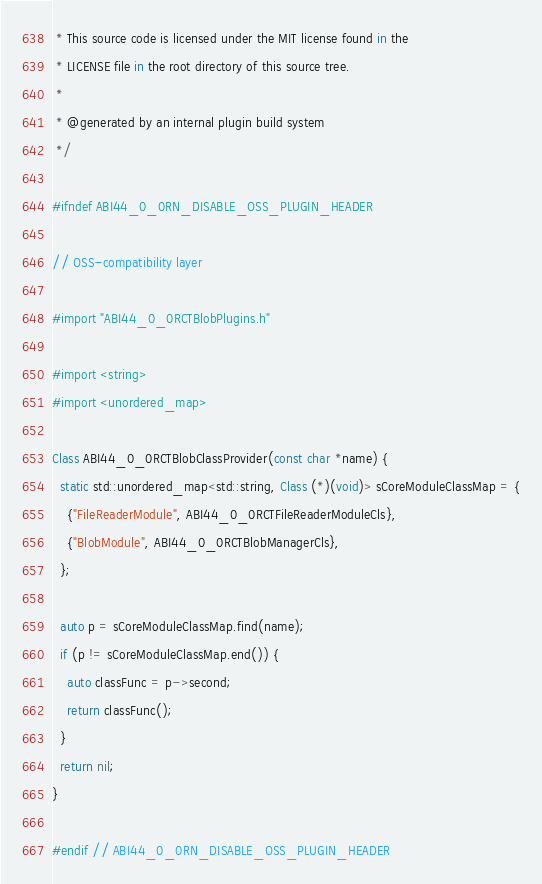<code> <loc_0><loc_0><loc_500><loc_500><_ObjectiveC_> * This source code is licensed under the MIT license found in the
 * LICENSE file in the root directory of this source tree.
 *
 * @generated by an internal plugin build system
 */

#ifndef ABI44_0_0RN_DISABLE_OSS_PLUGIN_HEADER

// OSS-compatibility layer

#import "ABI44_0_0RCTBlobPlugins.h"

#import <string>
#import <unordered_map>

Class ABI44_0_0RCTBlobClassProvider(const char *name) {
  static std::unordered_map<std::string, Class (*)(void)> sCoreModuleClassMap = {
    {"FileReaderModule", ABI44_0_0RCTFileReaderModuleCls},
    {"BlobModule", ABI44_0_0RCTBlobManagerCls},
  };

  auto p = sCoreModuleClassMap.find(name);
  if (p != sCoreModuleClassMap.end()) {
    auto classFunc = p->second;
    return classFunc();
  }
  return nil;
}

#endif // ABI44_0_0RN_DISABLE_OSS_PLUGIN_HEADER
</code> 